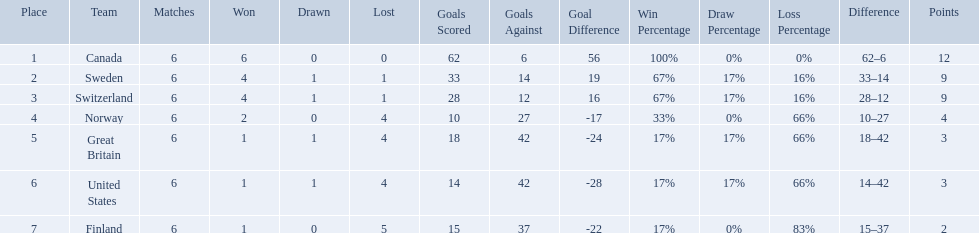Which are the two countries? Switzerland, Great Britain. What were the point totals for each of these countries? 9, 3. Of these point totals, which is better? 9. Which country earned this point total? Switzerland. Parse the full table. {'header': ['Place', 'Team', 'Matches', 'Won', 'Drawn', 'Lost', 'Goals Scored', 'Goals Against', 'Goal Difference', 'Win Percentage', 'Draw Percentage', 'Loss Percentage', 'Difference', 'Points'], 'rows': [['1', 'Canada', '6', '6', '0', '0', '62', '6', '56', '100%', '0%', '0%', '62–6', '12'], ['2', 'Sweden', '6', '4', '1', '1', '33', '14', '19', '67%', '17%', '16%', '33–14', '9'], ['3', 'Switzerland', '6', '4', '1', '1', '28', '12', '16', '67%', '17%', '16%', '28–12', '9'], ['4', 'Norway', '6', '2', '0', '4', '10', '27', '-17', '33%', '0%', '66%', '10–27', '4'], ['5', 'Great Britain', '6', '1', '1', '4', '18', '42', '-24', '17%', '17%', '66%', '18–42', '3'], ['6', 'United States', '6', '1', '1', '4', '14', '42', '-28', '17%', '17%', '66%', '14–42', '3'], ['7', 'Finland', '6', '1', '0', '5', '15', '37', '-22', '17%', '0%', '83%', '15–37', '2']]} 